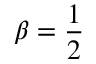<formula> <loc_0><loc_0><loc_500><loc_500>\beta = \frac { 1 } { 2 }</formula> 